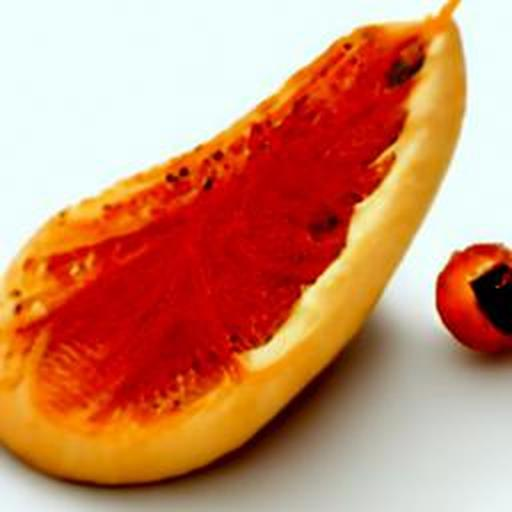Is the image properly focused? The image appears to be partially focused, with clear details visible on the surface of the fruit, showcasing its texture and color vividly, while other parts seem slightly less sharp. This selective focus might be intentional to draw the viewer's attention to specific aspects of the subject. 